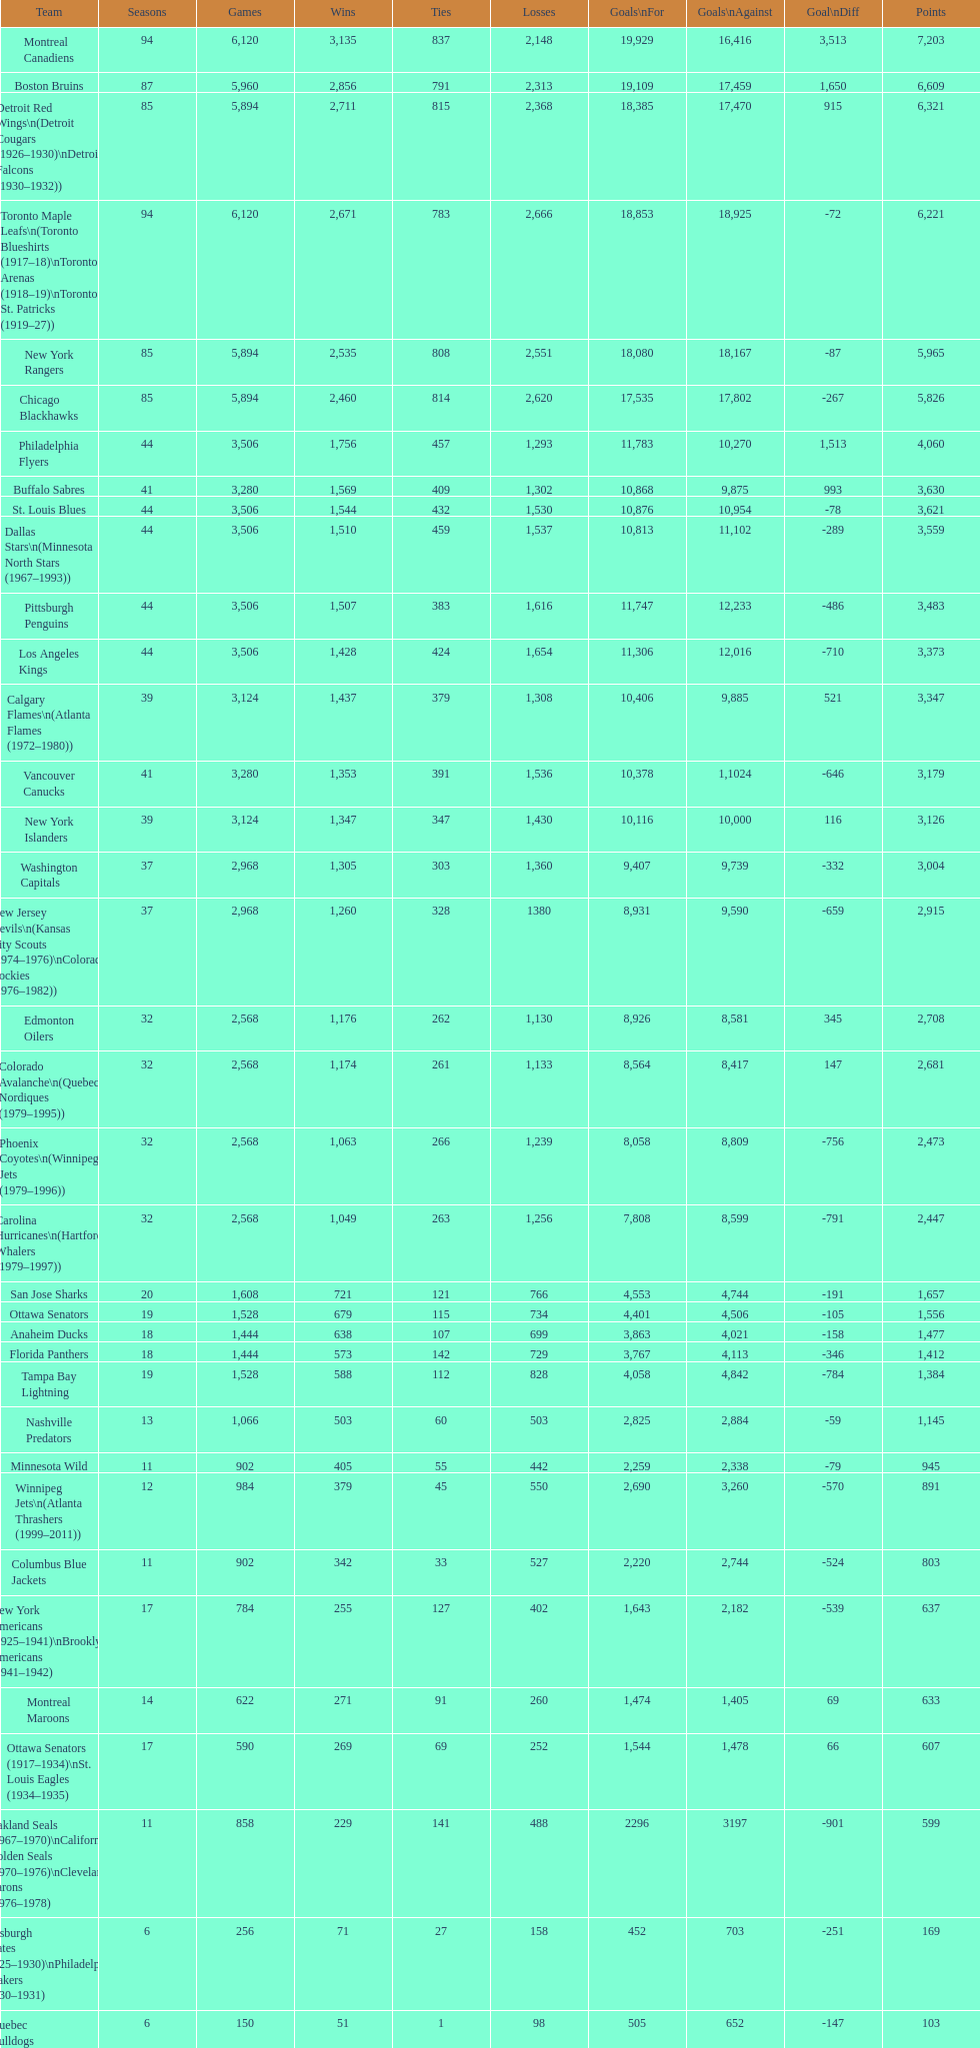How many total points has the lost angeles kings scored? 3,373. 